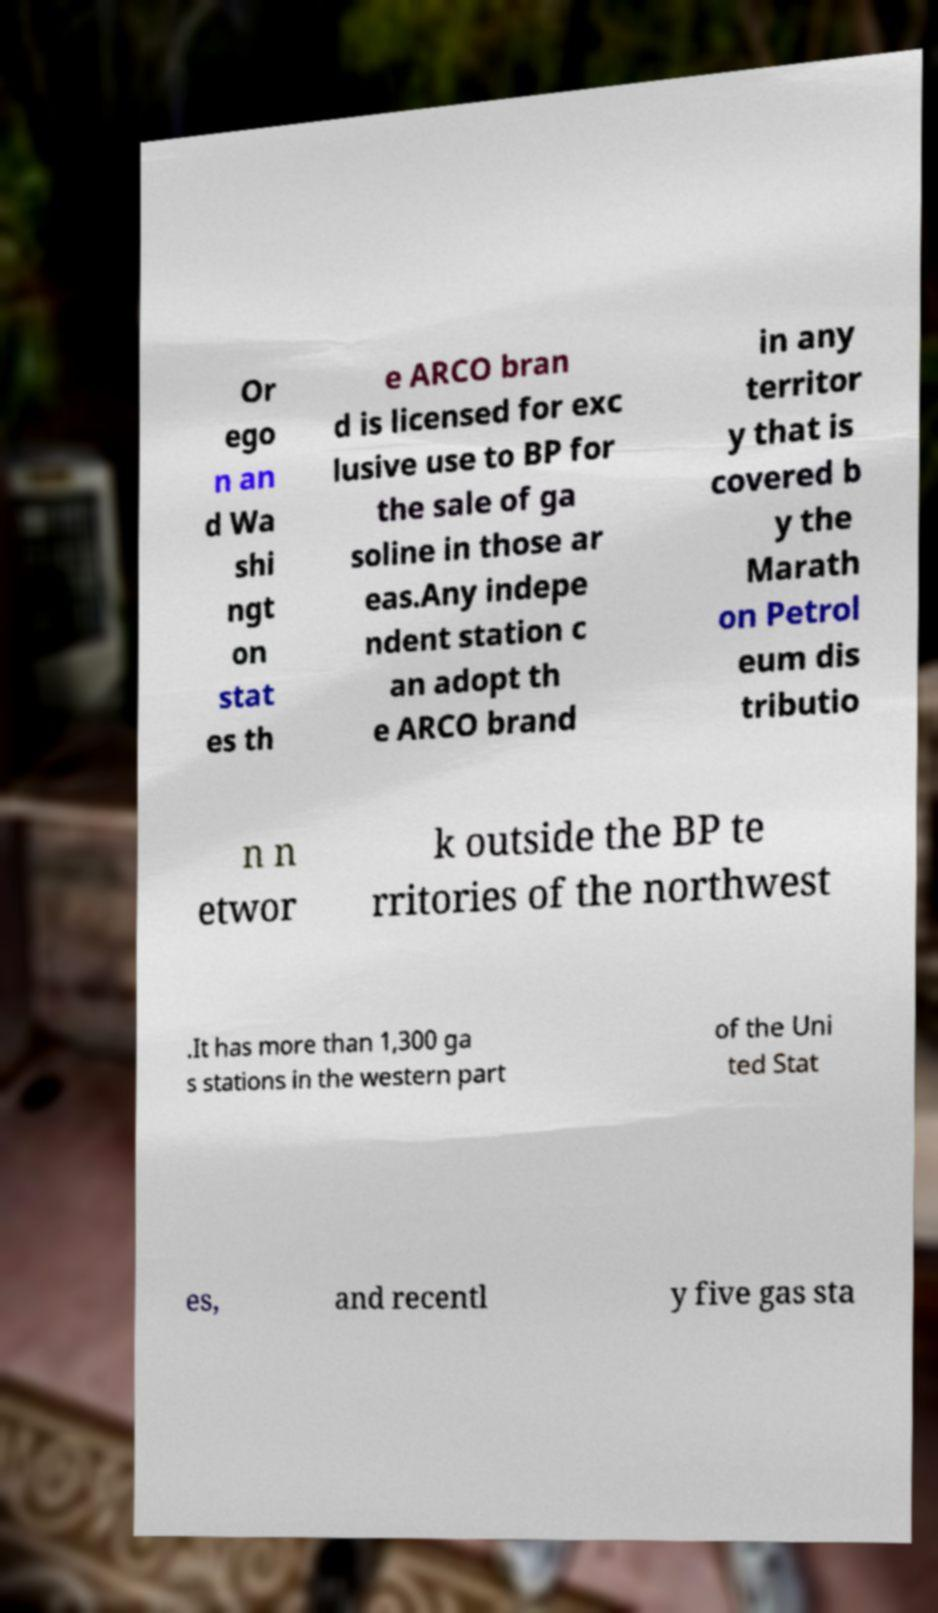For documentation purposes, I need the text within this image transcribed. Could you provide that? Or ego n an d Wa shi ngt on stat es th e ARCO bran d is licensed for exc lusive use to BP for the sale of ga soline in those ar eas.Any indepe ndent station c an adopt th e ARCO brand in any territor y that is covered b y the Marath on Petrol eum dis tributio n n etwor k outside the BP te rritories of the northwest .It has more than 1,300 ga s stations in the western part of the Uni ted Stat es, and recentl y five gas sta 